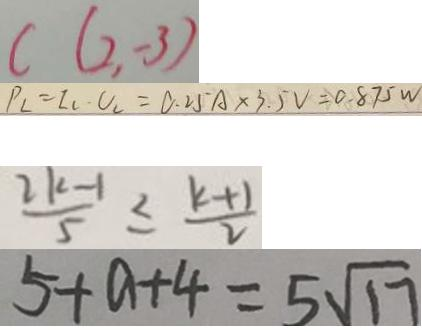Convert formula to latex. <formula><loc_0><loc_0><loc_500><loc_500>c ( 2 , - 3 ) 
 P _ { L } = I _ { L } \cdot U _ { L } = 0 . 2 5 A \times 3 . 5 V = 0 . 8 7 5 W 
 \frac { 2 k - 1 } { 5 } \leq \frac { k + 1 } { 2 } 
 5 + a + 4 = 5 \sqrt { 1 7 }</formula> 